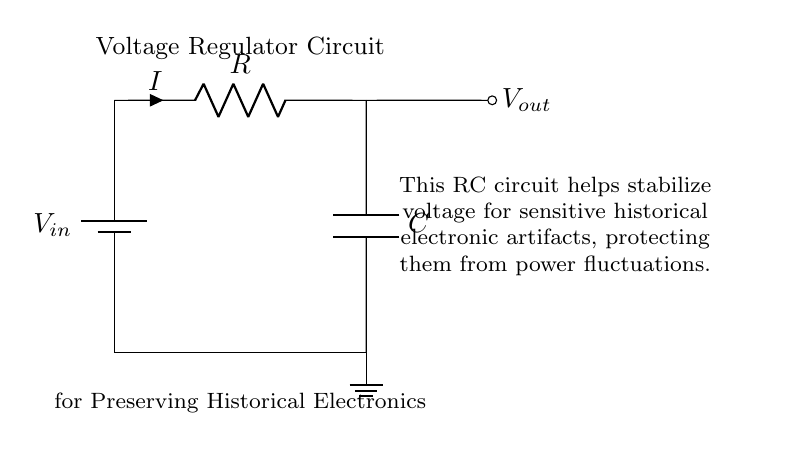What type of components are present in this circuit? The circuit includes a battery, resistor, and capacitor, which are the basic components visible.
Answer: battery, resistor, capacitor What does the capacitor do in this circuit? The capacitor helps stabilize the voltage output, smoothing out fluctuations for sensitive artifacts.
Answer: stabilize voltage What is the primary purpose of this RC circuit? The purpose is to preserve delicate historical electronic artifacts by regulating voltage and preventing damage from fluctuations.
Answer: preserve artifacts What is the voltage input denoted as in the circuit diagram? The voltage input is denoted as V in.
Answer: V in How does the resistor affect current in this circuit? The resistor limits the current flowing through the circuit, preventing too much current from reaching the capacitor, which protects the artifacts.
Answer: limits current What would happen if the capacitor were removed from the circuit? Without the capacitor, voltage fluctuations would not be smoothed out, potentially damaging sensitive historical electronics.
Answer: increased risk of damage 